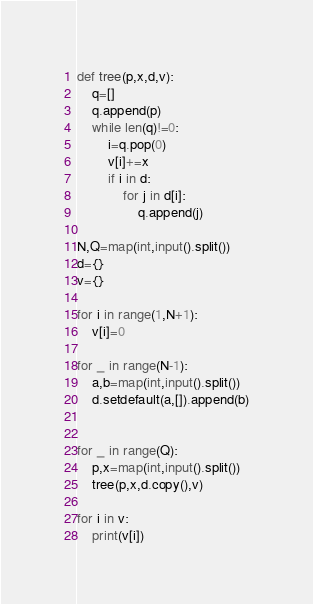<code> <loc_0><loc_0><loc_500><loc_500><_Python_>def tree(p,x,d,v):
    q=[]
    q.append(p)
    while len(q)!=0:
        i=q.pop(0)
        v[i]+=x
        if i in d:
            for j in d[i]:
                q.append(j)

N,Q=map(int,input().split())
d={}
v={}

for i in range(1,N+1):
    v[i]=0

for _ in range(N-1):
    a,b=map(int,input().split())
    d.setdefault(a,[]).append(b)


for _ in range(Q):
    p,x=map(int,input().split())
    tree(p,x,d.copy(),v)

for i in v:
    print(v[i])</code> 